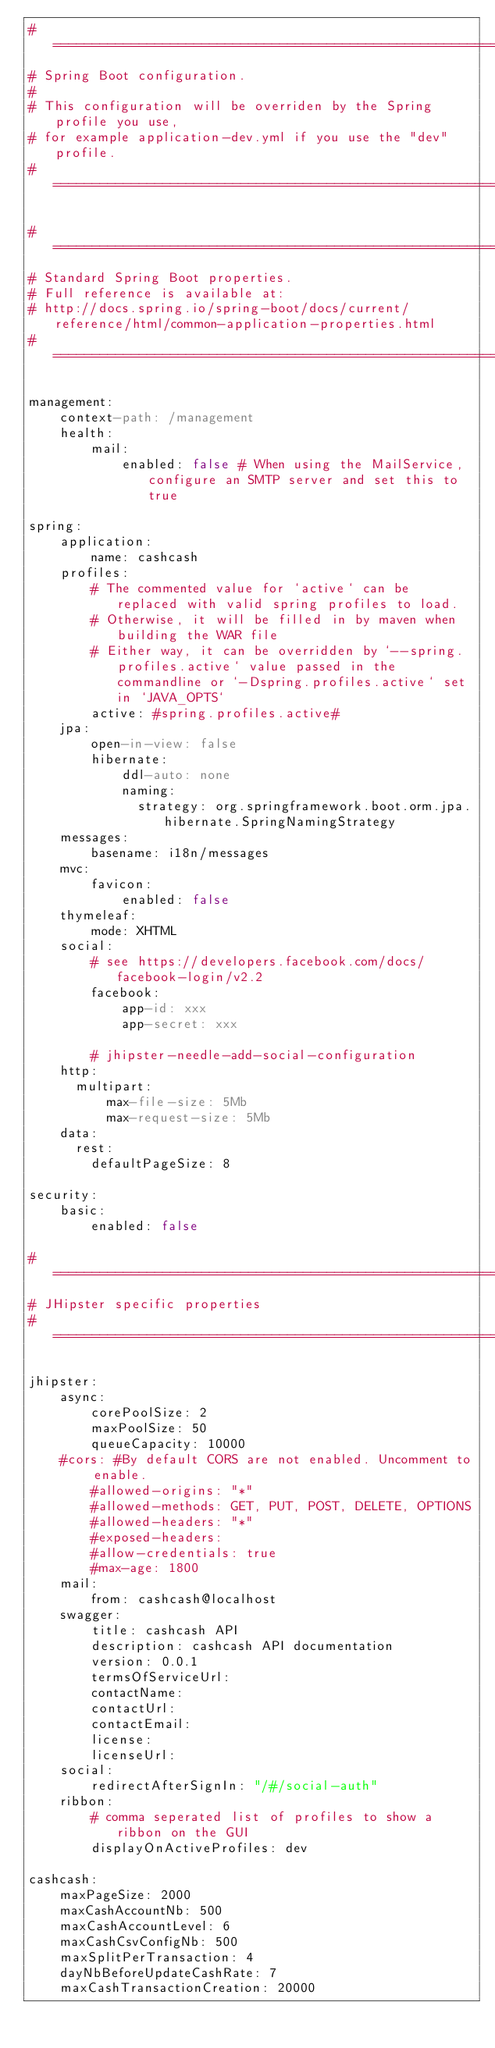Convert code to text. <code><loc_0><loc_0><loc_500><loc_500><_YAML_># ===================================================================
# Spring Boot configuration.
#
# This configuration will be overriden by the Spring profile you use,
# for example application-dev.yml if you use the "dev" profile.
# ===================================================================

# ===================================================================
# Standard Spring Boot properties.
# Full reference is available at:
# http://docs.spring.io/spring-boot/docs/current/reference/html/common-application-properties.html
# ===================================================================

management:
    context-path: /management
    health:
        mail:
            enabled: false # When using the MailService, configure an SMTP server and set this to true

spring:
    application:
        name: cashcash
    profiles:
        # The commented value for `active` can be replaced with valid spring profiles to load.
        # Otherwise, it will be filled in by maven when building the WAR file
        # Either way, it can be overridden by `--spring.profiles.active` value passed in the commandline or `-Dspring.profiles.active` set in `JAVA_OPTS`
        active: #spring.profiles.active#
    jpa:
        open-in-view: false
        hibernate:
            ddl-auto: none
            naming:
              strategy: org.springframework.boot.orm.jpa.hibernate.SpringNamingStrategy
    messages:
        basename: i18n/messages
    mvc:
        favicon:
            enabled: false
    thymeleaf:
        mode: XHTML
    social:
        # see https://developers.facebook.com/docs/facebook-login/v2.2
        facebook:
            app-id: xxx
            app-secret: xxx

        # jhipster-needle-add-social-configuration
    http:
      multipart:
          max-file-size: 5Mb
          max-request-size: 5Mb
    data:
      rest:
        defaultPageSize: 8

security:
    basic:
        enabled: false

# ===================================================================
# JHipster specific properties
# ===================================================================

jhipster:
    async:
        corePoolSize: 2
        maxPoolSize: 50
        queueCapacity: 10000
    #cors: #By default CORS are not enabled. Uncomment to enable.
        #allowed-origins: "*"
        #allowed-methods: GET, PUT, POST, DELETE, OPTIONS
        #allowed-headers: "*"
        #exposed-headers:
        #allow-credentials: true
        #max-age: 1800
    mail:
        from: cashcash@localhost
    swagger:
        title: cashcash API
        description: cashcash API documentation
        version: 0.0.1
        termsOfServiceUrl:
        contactName:
        contactUrl:
        contactEmail:
        license:
        licenseUrl:
    social:
        redirectAfterSignIn: "/#/social-auth"
    ribbon:
        # comma seperated list of profiles to show a ribbon on the GUI
        displayOnActiveProfiles: dev

cashcash:
    maxPageSize: 2000
    maxCashAccountNb: 500
    maxCashAccountLevel: 6
    maxCashCsvConfigNb: 500
    maxSplitPerTransaction: 4
    dayNbBeforeUpdateCashRate: 7
    maxCashTransactionCreation: 20000</code> 